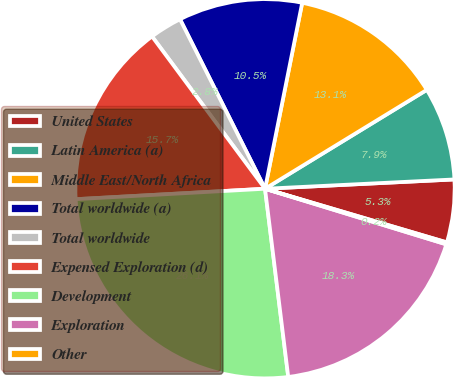Convert chart to OTSL. <chart><loc_0><loc_0><loc_500><loc_500><pie_chart><fcel>United States<fcel>Latin America (a)<fcel>Middle East/North Africa<fcel>Total worldwide (a)<fcel>Total worldwide<fcel>Expensed Exploration (d)<fcel>Development<fcel>Exploration<fcel>Other<nl><fcel>5.35%<fcel>7.95%<fcel>13.13%<fcel>10.54%<fcel>2.76%<fcel>15.72%<fcel>26.08%<fcel>18.31%<fcel>0.17%<nl></chart> 